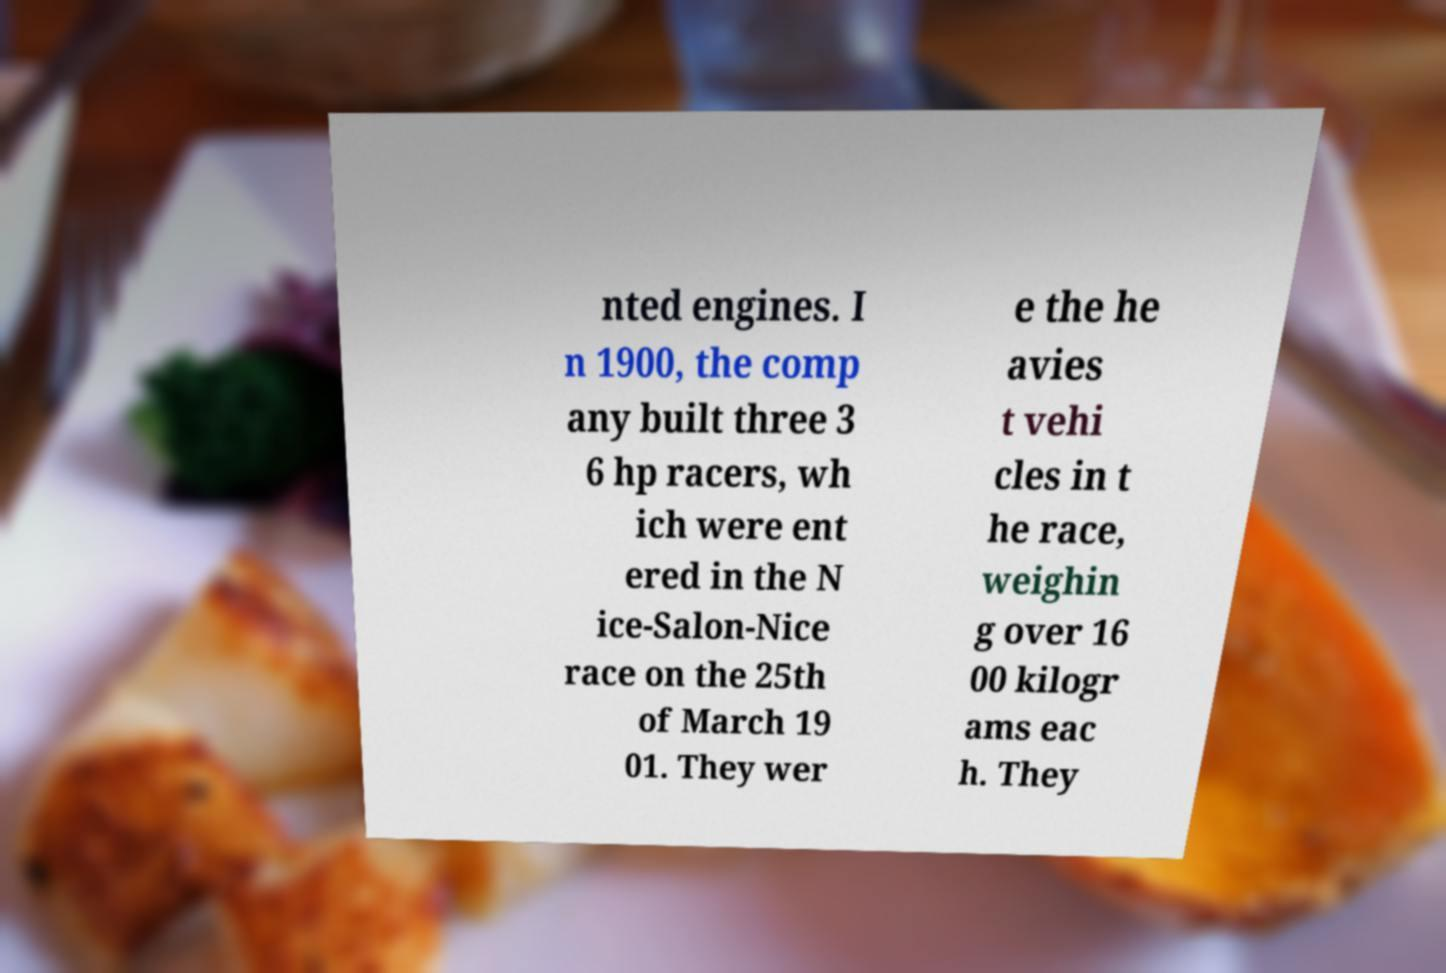Please identify and transcribe the text found in this image. nted engines. I n 1900, the comp any built three 3 6 hp racers, wh ich were ent ered in the N ice-Salon-Nice race on the 25th of March 19 01. They wer e the he avies t vehi cles in t he race, weighin g over 16 00 kilogr ams eac h. They 